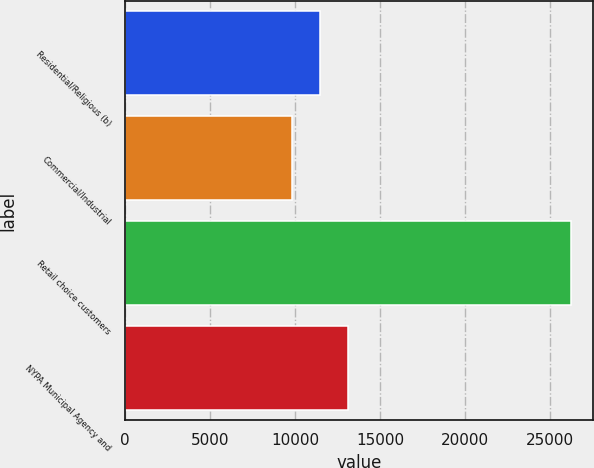Convert chart. <chart><loc_0><loc_0><loc_500><loc_500><bar_chart><fcel>Residential/Religious (b)<fcel>Commercial/Industrial<fcel>Retail choice customers<fcel>NYPA Municipal Agency and<nl><fcel>11472.7<fcel>9834<fcel>26221<fcel>13111.4<nl></chart> 